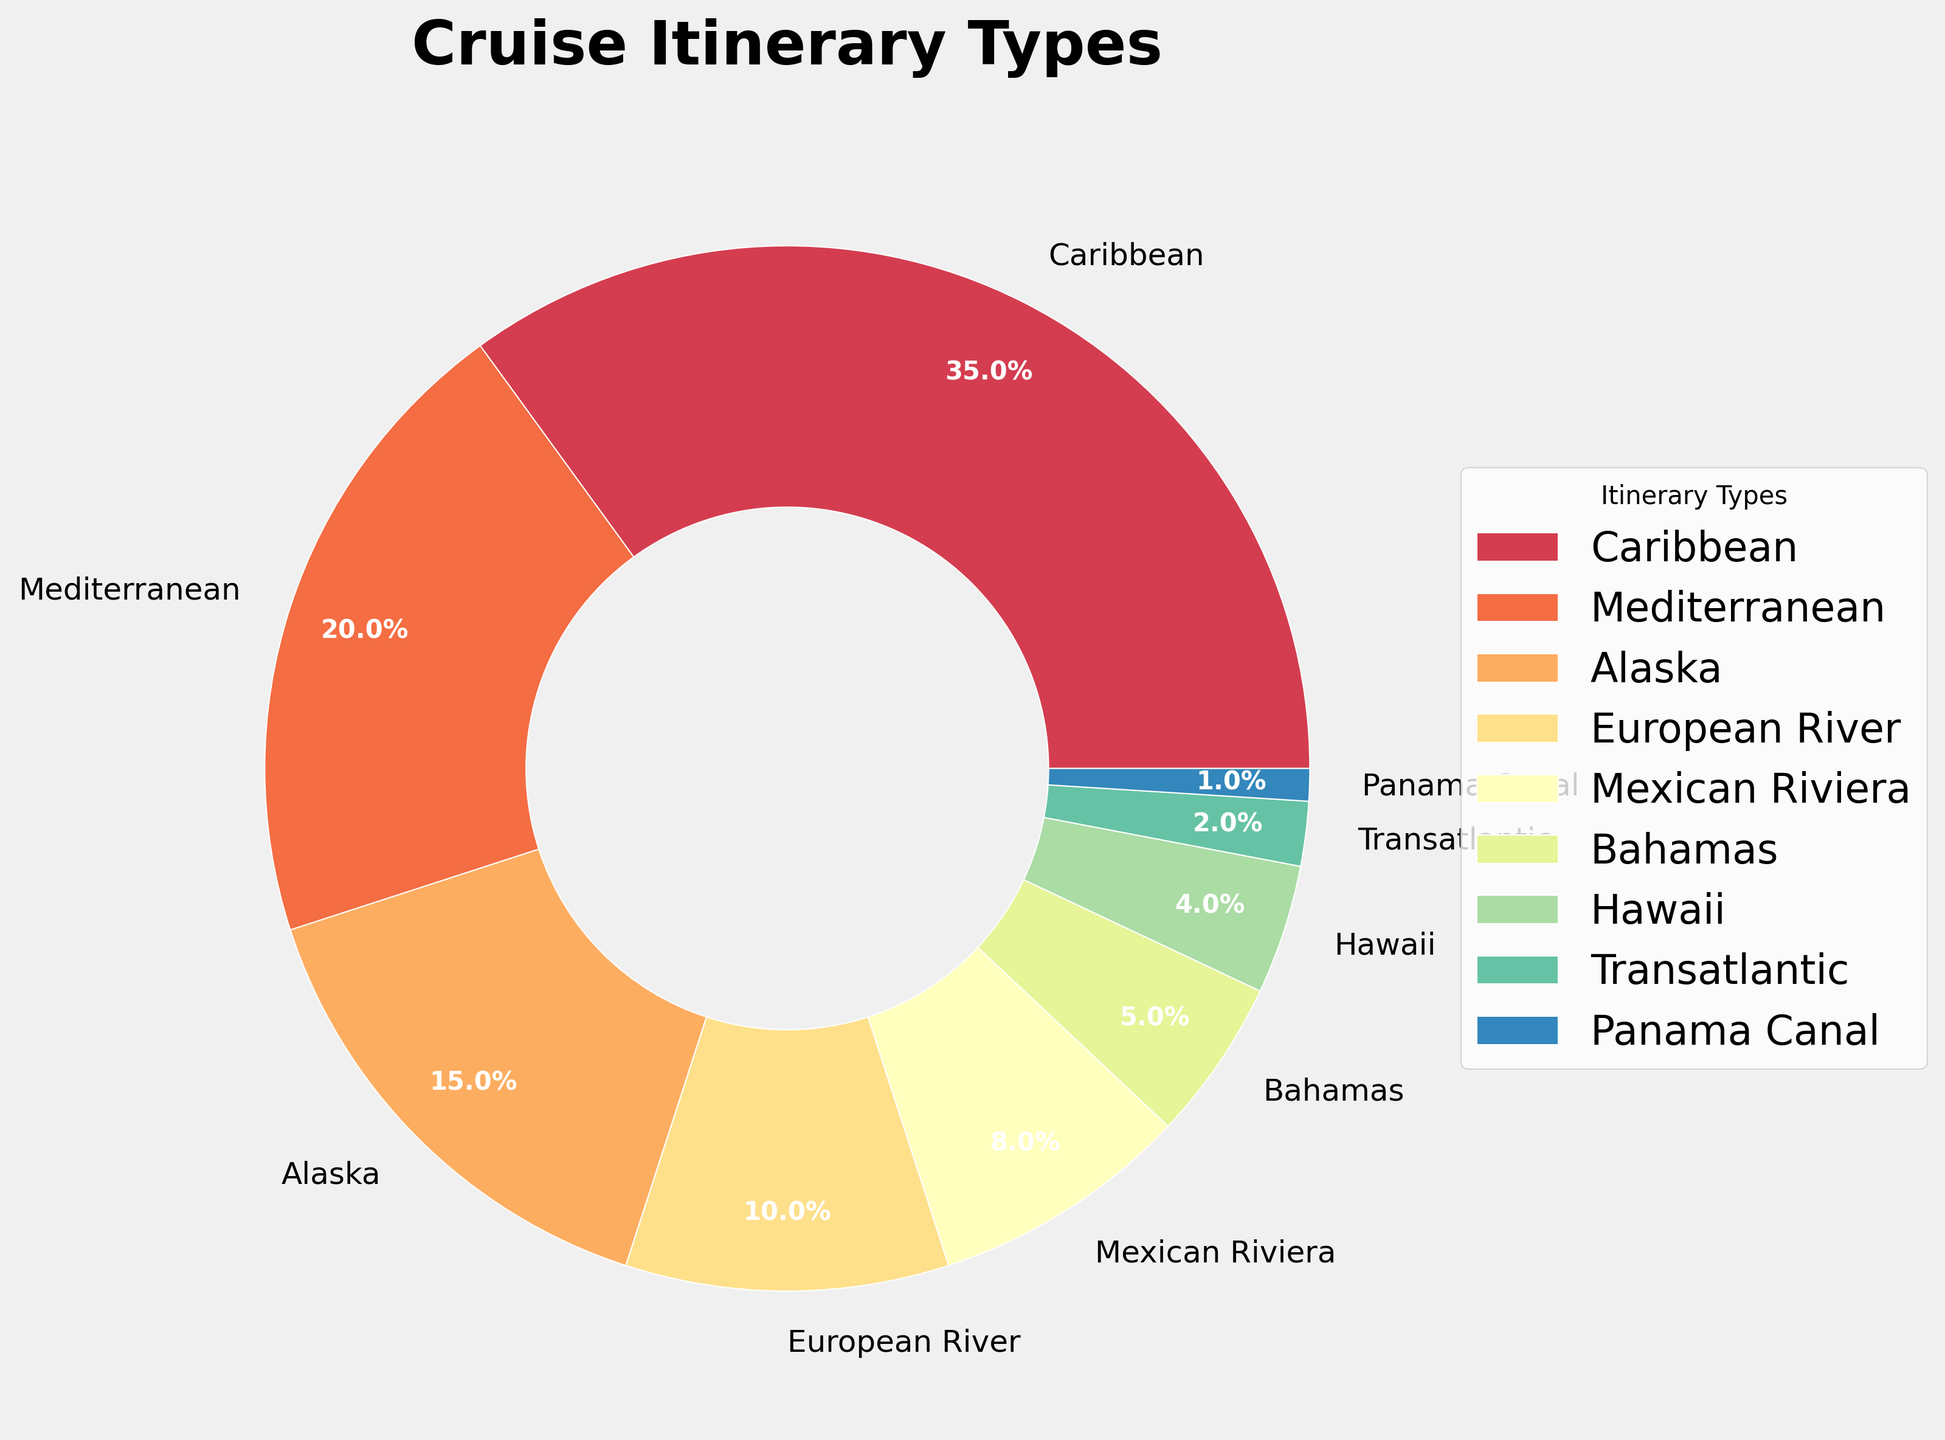What percentage of cruises are to the Caribbean? The pie chart shows the percentage breakdown of different cruise itineraries. Look for the segment labeled "Caribbean" and read its percentage directly.
Answer: 35% What is the combined percentage of Mediterranean and Alaska cruises? Identify the percentages for Mediterranean (20%) and Alaska (15%) from the pie chart, then add them together: 20% + 15% = 35%.
Answer: 35% Which itinerary type has the smallest percentage, and what is it? Locate the smallest segment in the pie chart and read its percentage and label. The smallest segment is labeled "Panama Canal" and is 1%.
Answer: Panama Canal, 1% How does the percentage of Bahamas cruises compare to Hawaiian cruises? Observe the segments labeled "Bahamas" and "Hawaii," and compare their percentages. Bahamas is 5%, while Hawaii is 4%, so Bahamas has a higher percentage.
Answer: Bahamas has a higher percentage (5% vs. 4%) What is the difference in percentage between European River and Mexican Riviera cruises? Identify the percentages for European River (10%) and Mexican Riviera (8%) segments and subtract the smaller from the larger: 10% - 8% = 2%.
Answer: 2% Which cruise itinerary types combined account for over 50% of the total? Add the percentages of different segments until the sum exceeds 50%. Caribbean (35%) + Mediterranean (20%) = 55%, which is already over 50%.
Answer: Caribbean and Mediterranean What proportion of cruises are taken to destinations other than Caribbean and Mediterranean? Find the combined percentage of Caribbean and Mediterranean cruises (35% + 20% = 55%) and subtract it from the total of 100%: 100% - 55% = 45%.
Answer: 45% Is the percentage of Transatlantic cruises greater than that of Hawaii cruises? Compare the segments labeled "Transatlantic" (2%) and "Hawaii" (4%). "Hawaii" (4%) is greater than "Transatlantic" (2%).
Answer: No, Hawaii is greater What is the total percentage for the top three cruise itineraries? Identify the top three segments by looking for the largest percentages: Caribbean (35%), Mediterranean (20%), Alaska (15%). Add these: 35% + 20% + 15% = 70%.
Answer: 70% How does the percentage of Alaska cruises compare to that of European River cruises? Observe the segments labeled "Alaska" (15%) and "European River" (10%), and compare their percentages. Alaska has a higher percentage.
Answer: Alaska has a higher percentage (15% vs. 10%) 